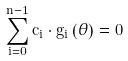<formula> <loc_0><loc_0><loc_500><loc_500>\sum _ { i = 0 } ^ { n - 1 } c _ { i } \cdot g _ { i } \left ( \theta \right ) = 0</formula> 